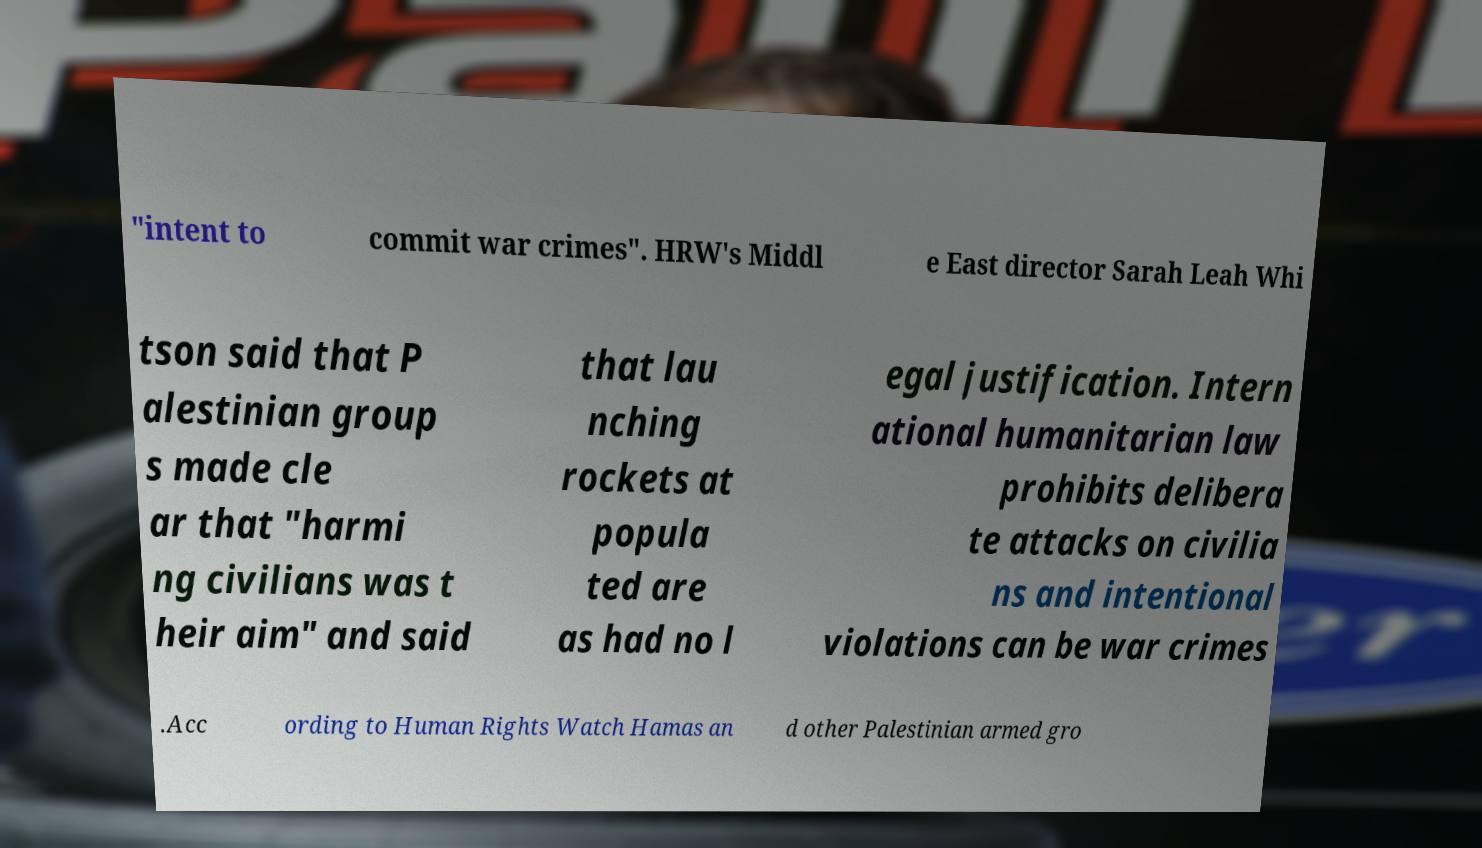Please read and relay the text visible in this image. What does it say? "intent to commit war crimes". HRW's Middl e East director Sarah Leah Whi tson said that P alestinian group s made cle ar that "harmi ng civilians was t heir aim" and said that lau nching rockets at popula ted are as had no l egal justification. Intern ational humanitarian law prohibits delibera te attacks on civilia ns and intentional violations can be war crimes .Acc ording to Human Rights Watch Hamas an d other Palestinian armed gro 